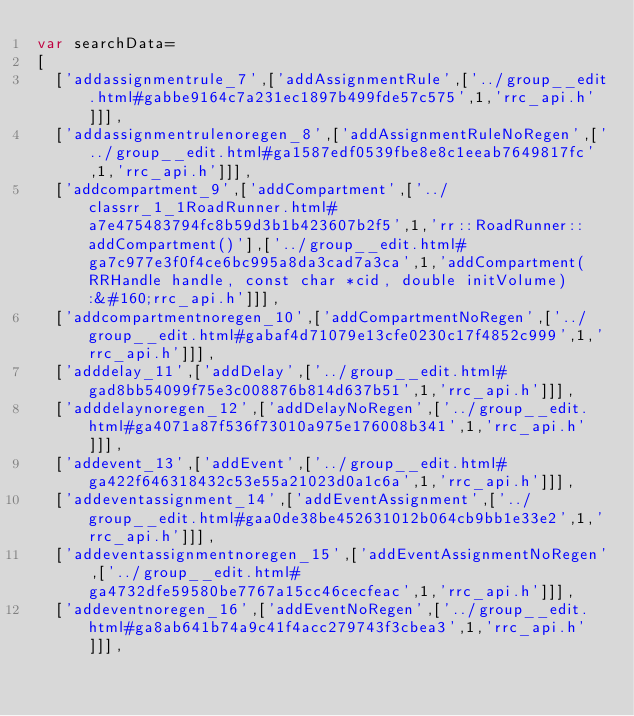<code> <loc_0><loc_0><loc_500><loc_500><_JavaScript_>var searchData=
[
  ['addassignmentrule_7',['addAssignmentRule',['../group__edit.html#gabbe9164c7a231ec1897b499fde57c575',1,'rrc_api.h']]],
  ['addassignmentrulenoregen_8',['addAssignmentRuleNoRegen',['../group__edit.html#ga1587edf0539fbe8e8c1eeab7649817fc',1,'rrc_api.h']]],
  ['addcompartment_9',['addCompartment',['../classrr_1_1RoadRunner.html#a7e475483794fc8b59d3b1b423607b2f5',1,'rr::RoadRunner::addCompartment()'],['../group__edit.html#ga7c977e3f0f4ce6bc995a8da3cad7a3ca',1,'addCompartment(RRHandle handle, const char *cid, double initVolume):&#160;rrc_api.h']]],
  ['addcompartmentnoregen_10',['addCompartmentNoRegen',['../group__edit.html#gabaf4d71079e13cfe0230c17f4852c999',1,'rrc_api.h']]],
  ['adddelay_11',['addDelay',['../group__edit.html#gad8bb54099f75e3c008876b814d637b51',1,'rrc_api.h']]],
  ['adddelaynoregen_12',['addDelayNoRegen',['../group__edit.html#ga4071a87f536f73010a975e176008b341',1,'rrc_api.h']]],
  ['addevent_13',['addEvent',['../group__edit.html#ga422f646318432c53e55a21023d0a1c6a',1,'rrc_api.h']]],
  ['addeventassignment_14',['addEventAssignment',['../group__edit.html#gaa0de38be452631012b064cb9bb1e33e2',1,'rrc_api.h']]],
  ['addeventassignmentnoregen_15',['addEventAssignmentNoRegen',['../group__edit.html#ga4732dfe59580be7767a15cc46cecfeac',1,'rrc_api.h']]],
  ['addeventnoregen_16',['addEventNoRegen',['../group__edit.html#ga8ab641b74a9c41f4acc279743f3cbea3',1,'rrc_api.h']]],</code> 